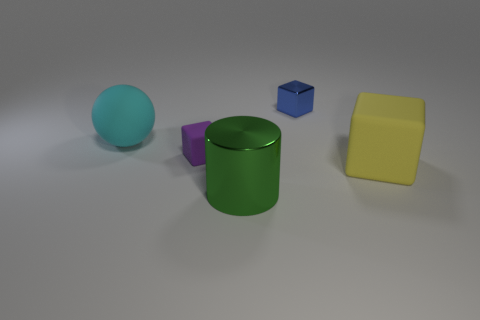Add 4 large green metallic cylinders. How many objects exist? 9 Subtract all balls. How many objects are left? 4 Add 1 large yellow matte blocks. How many large yellow matte blocks are left? 2 Add 4 large cylinders. How many large cylinders exist? 5 Subtract 0 gray balls. How many objects are left? 5 Subtract all cyan rubber cylinders. Subtract all big cylinders. How many objects are left? 4 